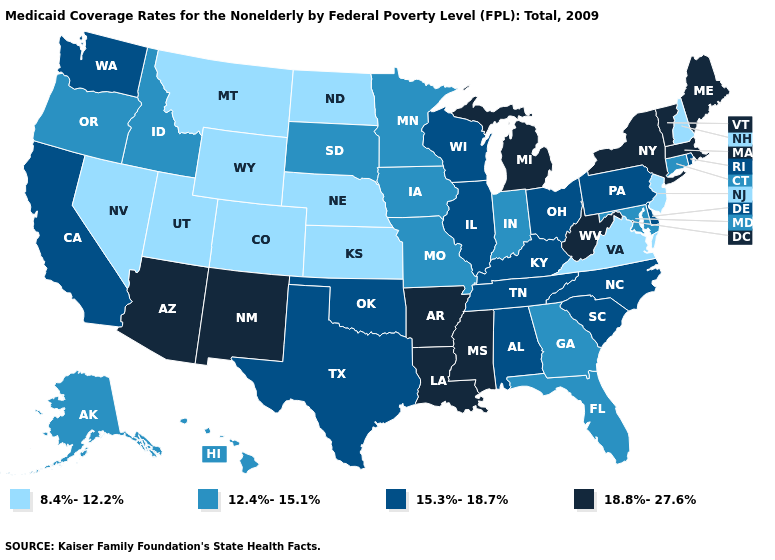Name the states that have a value in the range 15.3%-18.7%?
Be succinct. Alabama, California, Delaware, Illinois, Kentucky, North Carolina, Ohio, Oklahoma, Pennsylvania, Rhode Island, South Carolina, Tennessee, Texas, Washington, Wisconsin. Which states have the highest value in the USA?
Short answer required. Arizona, Arkansas, Louisiana, Maine, Massachusetts, Michigan, Mississippi, New Mexico, New York, Vermont, West Virginia. Does Arkansas have the highest value in the USA?
Concise answer only. Yes. Does the first symbol in the legend represent the smallest category?
Be succinct. Yes. What is the value of Maine?
Quick response, please. 18.8%-27.6%. Among the states that border Wisconsin , does Michigan have the highest value?
Be succinct. Yes. What is the value of West Virginia?
Quick response, please. 18.8%-27.6%. Does Pennsylvania have the lowest value in the Northeast?
Keep it brief. No. What is the lowest value in the USA?
Quick response, please. 8.4%-12.2%. What is the lowest value in the South?
Give a very brief answer. 8.4%-12.2%. Name the states that have a value in the range 15.3%-18.7%?
Write a very short answer. Alabama, California, Delaware, Illinois, Kentucky, North Carolina, Ohio, Oklahoma, Pennsylvania, Rhode Island, South Carolina, Tennessee, Texas, Washington, Wisconsin. What is the lowest value in states that border Arkansas?
Be succinct. 12.4%-15.1%. Among the states that border Tennessee , does Kentucky have the lowest value?
Give a very brief answer. No. Which states hav the highest value in the MidWest?
Concise answer only. Michigan. Does Maine have a higher value than California?
Concise answer only. Yes. 